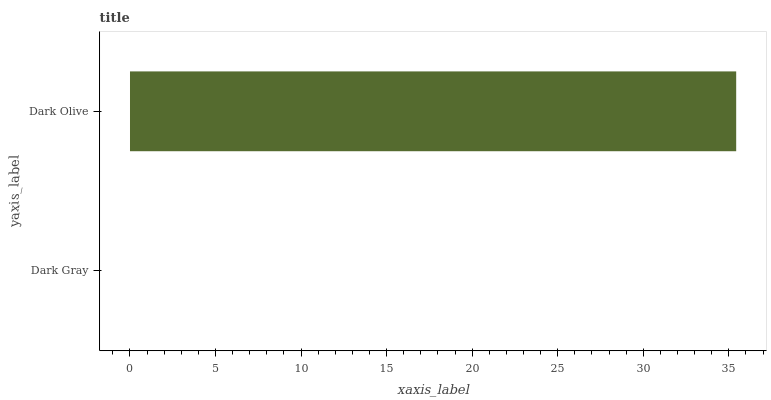Is Dark Gray the minimum?
Answer yes or no. Yes. Is Dark Olive the maximum?
Answer yes or no. Yes. Is Dark Olive the minimum?
Answer yes or no. No. Is Dark Olive greater than Dark Gray?
Answer yes or no. Yes. Is Dark Gray less than Dark Olive?
Answer yes or no. Yes. Is Dark Gray greater than Dark Olive?
Answer yes or no. No. Is Dark Olive less than Dark Gray?
Answer yes or no. No. Is Dark Olive the high median?
Answer yes or no. Yes. Is Dark Gray the low median?
Answer yes or no. Yes. Is Dark Gray the high median?
Answer yes or no. No. Is Dark Olive the low median?
Answer yes or no. No. 